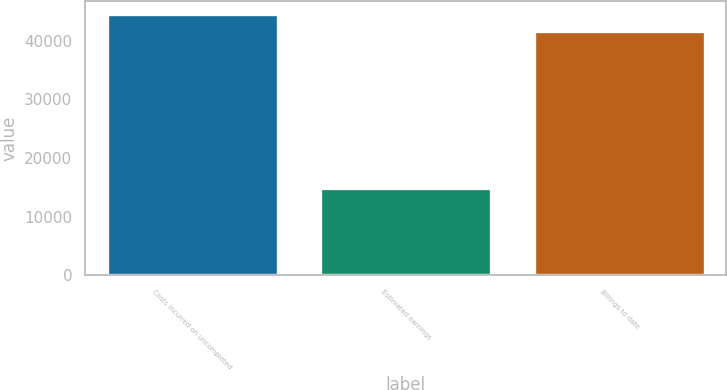Convert chart. <chart><loc_0><loc_0><loc_500><loc_500><bar_chart><fcel>Costs incurred on uncompleted<fcel>Estimated earnings<fcel>Billings to date<nl><fcel>44615.7<fcel>14809<fcel>41728<nl></chart> 